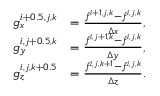<formula> <loc_0><loc_0><loc_500><loc_500>\begin{array} { r l } { g _ { x } ^ { i + 0 . 5 , j , k } } & { = \frac { f ^ { i + 1 , j , k } - f ^ { i , j , k } } { \Delta x } , } \\ { g _ { y } ^ { i , j + 0 . 5 , k } } & { = \frac { f ^ { i , j + 1 , k } - f ^ { i , j , k } } { \Delta y } , } \\ { g _ { z } ^ { i , j , k + 0 . 5 } } & { = \frac { f ^ { i , j , k + 1 } - f ^ { i , j , k } } { \Delta z } . } \end{array}</formula> 